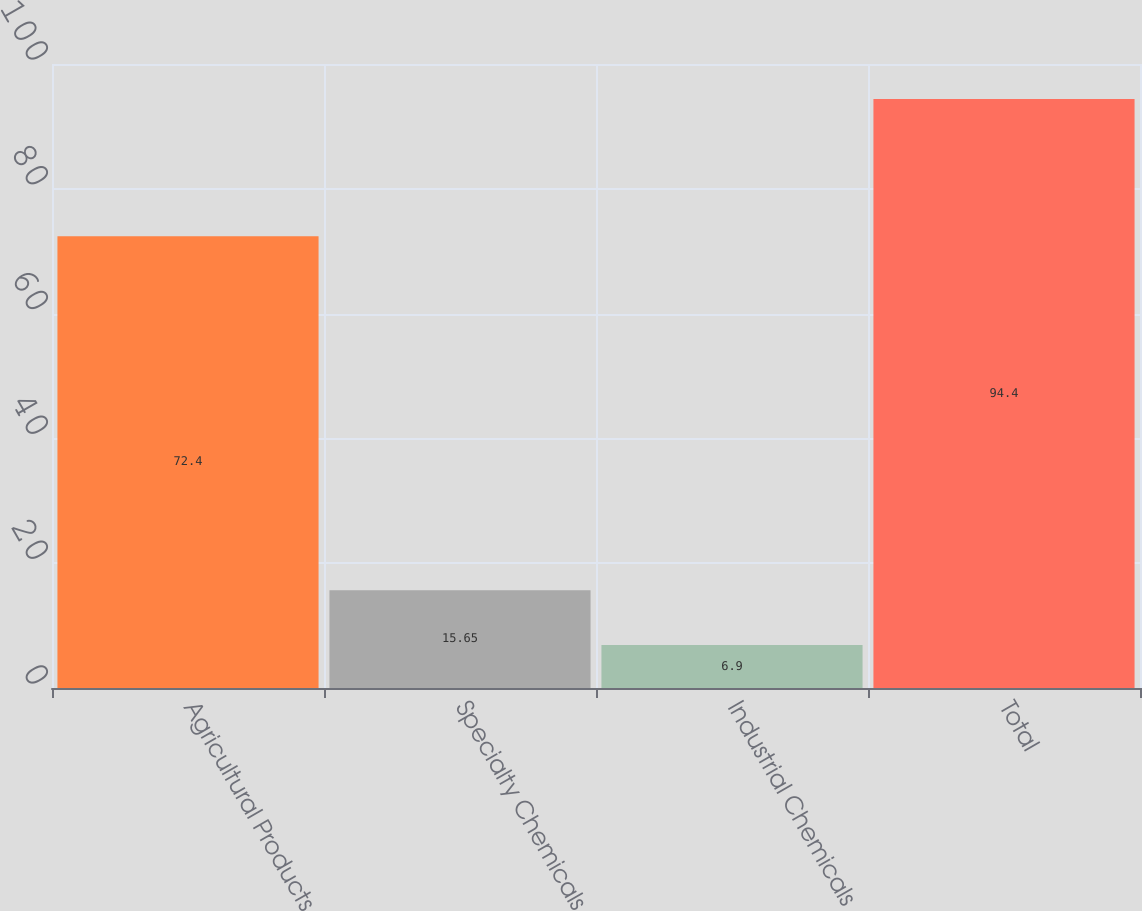Convert chart to OTSL. <chart><loc_0><loc_0><loc_500><loc_500><bar_chart><fcel>Agricultural Products<fcel>Specialty Chemicals<fcel>Industrial Chemicals<fcel>Total<nl><fcel>72.4<fcel>15.65<fcel>6.9<fcel>94.4<nl></chart> 